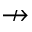Convert formula to latex. <formula><loc_0><loc_0><loc_500><loc_500>\nrightarrow</formula> 